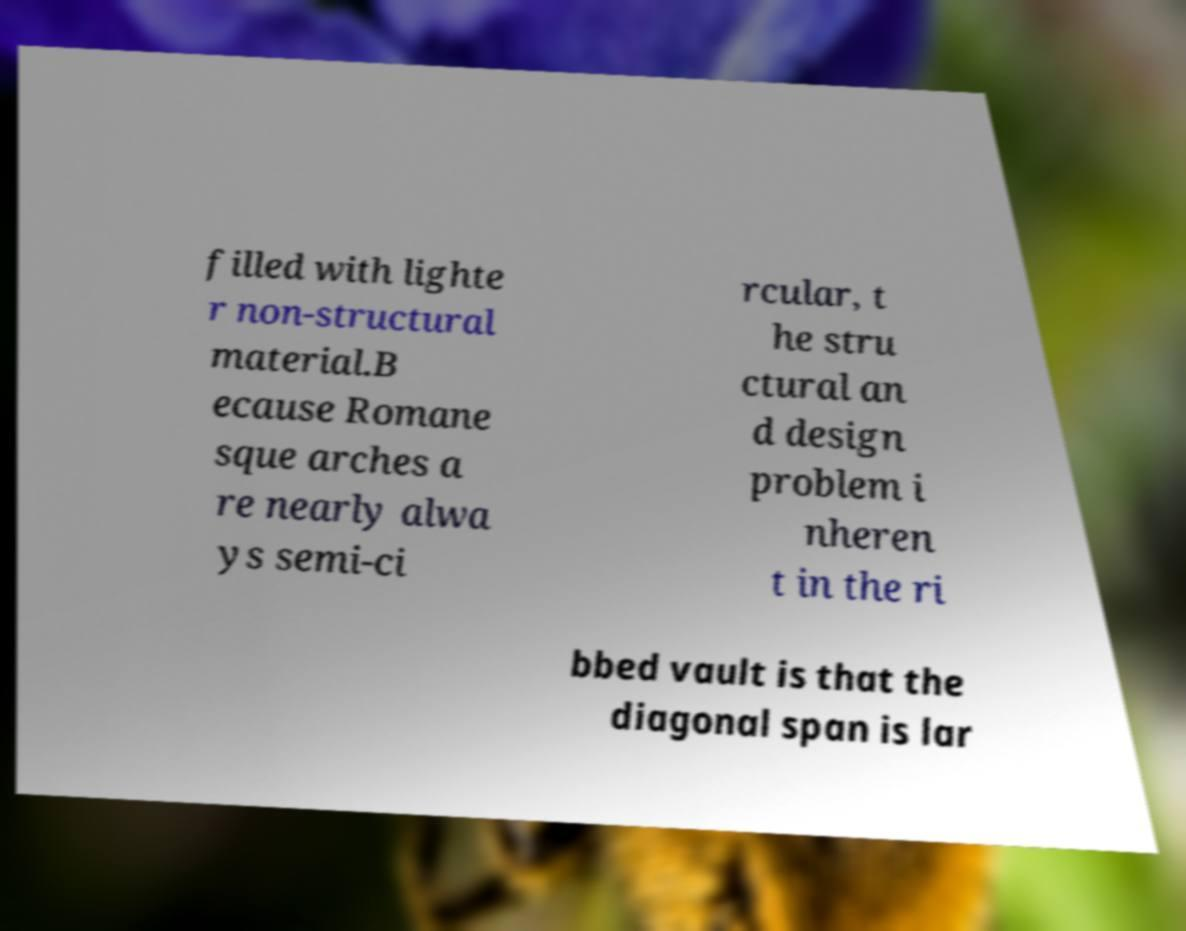Can you read and provide the text displayed in the image?This photo seems to have some interesting text. Can you extract and type it out for me? filled with lighte r non-structural material.B ecause Romane sque arches a re nearly alwa ys semi-ci rcular, t he stru ctural an d design problem i nheren t in the ri bbed vault is that the diagonal span is lar 